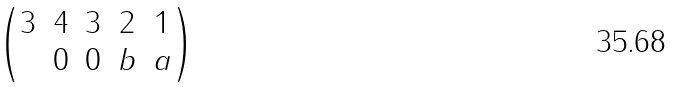Convert formula to latex. <formula><loc_0><loc_0><loc_500><loc_500>\begin{pmatrix} 3 & 4 & 3 & 2 & 1 \\ & 0 & 0 & b & a \end{pmatrix}</formula> 